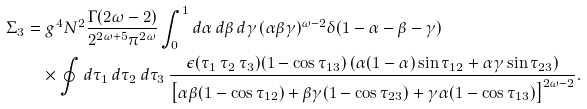Convert formula to latex. <formula><loc_0><loc_0><loc_500><loc_500>\Sigma _ { 3 } & = g ^ { 4 } N ^ { 2 } \frac { \Gamma ( 2 \omega - 2 ) } { 2 ^ { 2 \omega + 5 } \pi ^ { 2 \omega } } \int _ { 0 } ^ { 1 } d \alpha \, d \beta \, d \gamma \, ( \alpha \beta \gamma ) ^ { \omega - 2 } \delta ( 1 - \alpha - \beta - \gamma ) \\ & \quad \times \oint d \tau _ { 1 } \, d \tau _ { 2 } \, d \tau _ { 3 } \, \frac { \epsilon ( \tau _ { 1 } \, \tau _ { 2 } \, \tau _ { 3 } ) ( 1 - \cos \tau _ { 1 3 } ) \left ( \alpha ( 1 - \alpha ) \sin \tau _ { 1 2 } + \alpha \gamma \sin \tau _ { 2 3 } \right ) } { \left [ \alpha \beta ( 1 - \cos \tau _ { 1 2 } ) + \beta \gamma ( 1 - \cos \tau _ { 2 3 } ) + \gamma \alpha ( 1 - \cos \tau _ { 1 3 } ) \right ] ^ { 2 \omega - 2 } } .</formula> 